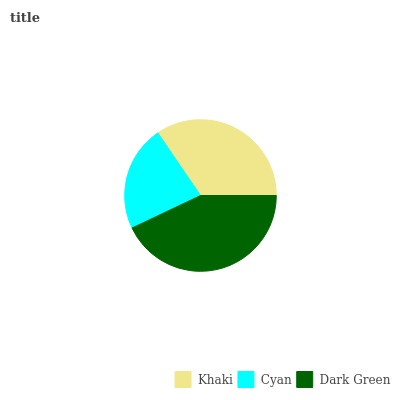Is Cyan the minimum?
Answer yes or no. Yes. Is Dark Green the maximum?
Answer yes or no. Yes. Is Dark Green the minimum?
Answer yes or no. No. Is Cyan the maximum?
Answer yes or no. No. Is Dark Green greater than Cyan?
Answer yes or no. Yes. Is Cyan less than Dark Green?
Answer yes or no. Yes. Is Cyan greater than Dark Green?
Answer yes or no. No. Is Dark Green less than Cyan?
Answer yes or no. No. Is Khaki the high median?
Answer yes or no. Yes. Is Khaki the low median?
Answer yes or no. Yes. Is Cyan the high median?
Answer yes or no. No. Is Cyan the low median?
Answer yes or no. No. 